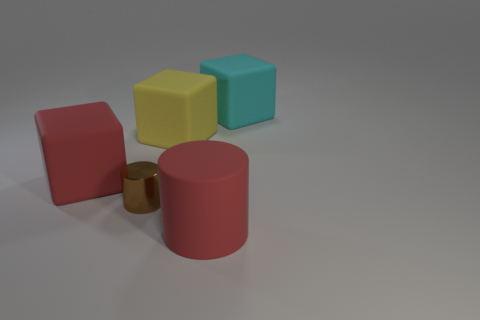Add 2 cyan blocks. How many objects exist? 7 Subtract all cylinders. How many objects are left? 3 Subtract 0 cyan cylinders. How many objects are left? 5 Subtract all yellow matte blocks. Subtract all rubber things. How many objects are left? 0 Add 4 large yellow rubber cubes. How many large yellow rubber cubes are left? 5 Add 4 large yellow shiny objects. How many large yellow shiny objects exist? 4 